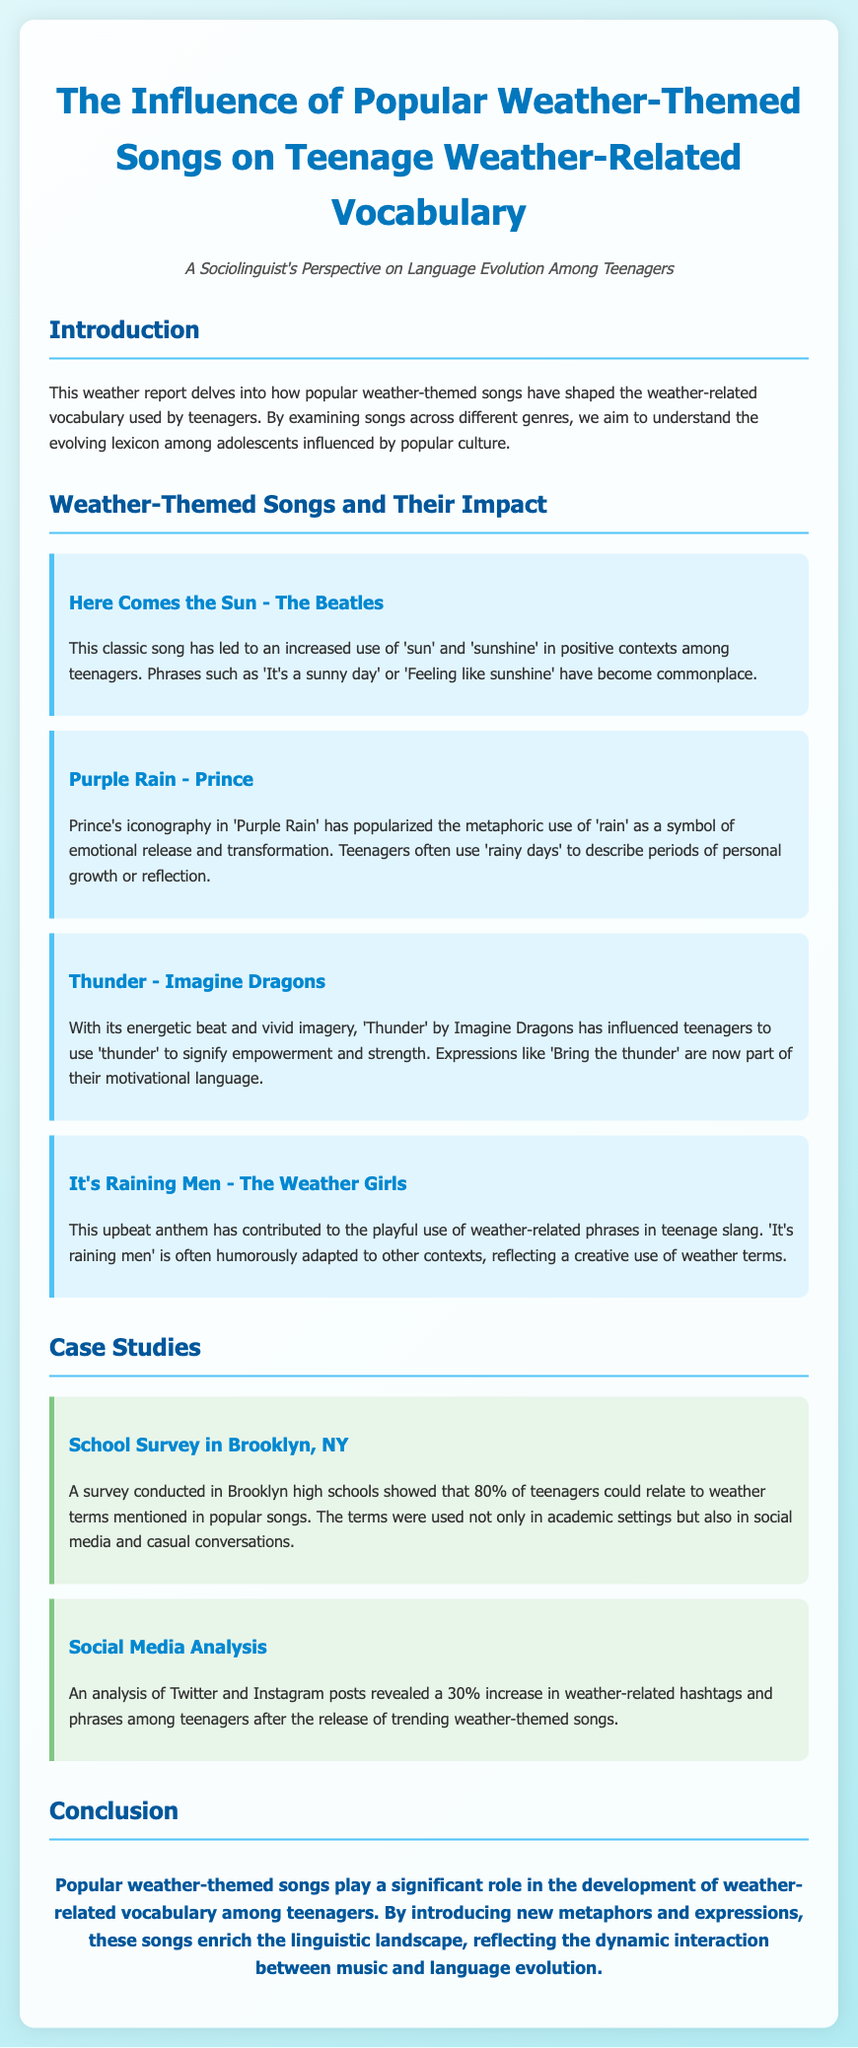What is the title of the document? The title of the document is provided in the header section, stating its focus on teenage vocabulary influenced by weather-themed songs.
Answer: The Influence of Popular Weather-Themed Songs on Teenage Weather-Related Vocabulary Which song is associated with the phrase "Feeling like sunshine"? The phrase is connected to the song "Here Comes the Sun" by The Beatles, which discusses positive contexts linked to 'sun' and 'sunshine'.
Answer: Here Comes the Sun What percentage of teenagers in a Brooklyn survey relate to weather terms in popular songs? The survey conducted showed that 80% of teenagers could relate to the weather terms mentioned in the songs.
Answer: 80% What metaphorical use of 'rain' is popularized by Prince's song? The song "Purple Rain" has popularized the use of 'rain' as a symbol of emotional release and transformation.
Answer: Emotional release What was the increase percentage in weather-related hashtags on social media after popular song releases? The analysis revealed a significant increase in weather-related hashtags and phrases after song releases, quantified as 30%.
Answer: 30% Which phrase reflects a playful use of weather-related terms? The phrase "It's raining men" from the song by The Weather Girls is humorously adapted in various contexts.
Answer: It's raining men What is the main conclusion of the document? The conclusion summarizes the significant role of weather-themed songs in enriching weather-related vocabulary among teenagers.
Answer: Enrich the linguistic landscape Which band performed the song "Thunder"? The song "Thunder" is performed by Imagine Dragons, as noted in its influence on the use of 'thunder' among teenagers.
Answer: Imagine Dragons 